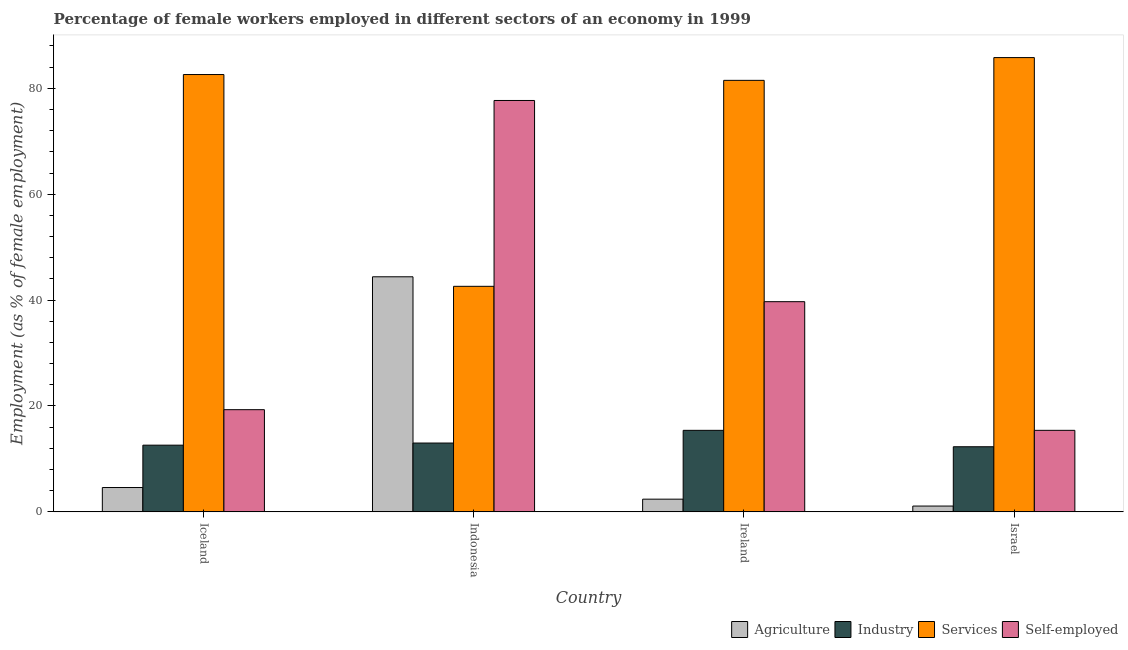How many groups of bars are there?
Your answer should be compact. 4. Are the number of bars per tick equal to the number of legend labels?
Your answer should be very brief. Yes. Are the number of bars on each tick of the X-axis equal?
Provide a succinct answer. Yes. How many bars are there on the 1st tick from the left?
Make the answer very short. 4. How many bars are there on the 4th tick from the right?
Your answer should be compact. 4. In how many cases, is the number of bars for a given country not equal to the number of legend labels?
Your response must be concise. 0. What is the percentage of self employed female workers in Israel?
Provide a succinct answer. 15.4. Across all countries, what is the maximum percentage of female workers in agriculture?
Offer a terse response. 44.4. Across all countries, what is the minimum percentage of female workers in services?
Ensure brevity in your answer.  42.6. In which country was the percentage of female workers in industry maximum?
Give a very brief answer. Ireland. In which country was the percentage of self employed female workers minimum?
Keep it short and to the point. Israel. What is the total percentage of female workers in services in the graph?
Offer a very short reply. 292.5. What is the difference between the percentage of self employed female workers in Iceland and that in Ireland?
Offer a very short reply. -20.4. What is the difference between the percentage of female workers in services in Israel and the percentage of self employed female workers in Iceland?
Your answer should be compact. 66.5. What is the average percentage of self employed female workers per country?
Your answer should be compact. 38.02. What is the difference between the percentage of female workers in agriculture and percentage of self employed female workers in Indonesia?
Your answer should be very brief. -33.3. In how many countries, is the percentage of female workers in services greater than 12 %?
Provide a succinct answer. 4. What is the ratio of the percentage of female workers in agriculture in Iceland to that in Indonesia?
Keep it short and to the point. 0.1. What is the difference between the highest and the second highest percentage of female workers in agriculture?
Your answer should be compact. 39.8. What is the difference between the highest and the lowest percentage of female workers in agriculture?
Your answer should be very brief. 43.3. In how many countries, is the percentage of female workers in industry greater than the average percentage of female workers in industry taken over all countries?
Ensure brevity in your answer.  1. Is the sum of the percentage of female workers in services in Iceland and Ireland greater than the maximum percentage of female workers in agriculture across all countries?
Your response must be concise. Yes. Is it the case that in every country, the sum of the percentage of female workers in services and percentage of self employed female workers is greater than the sum of percentage of female workers in agriculture and percentage of female workers in industry?
Give a very brief answer. No. What does the 3rd bar from the left in Ireland represents?
Offer a terse response. Services. What does the 2nd bar from the right in Indonesia represents?
Give a very brief answer. Services. How many bars are there?
Make the answer very short. 16. Are all the bars in the graph horizontal?
Your response must be concise. No. How many countries are there in the graph?
Ensure brevity in your answer.  4. What is the difference between two consecutive major ticks on the Y-axis?
Your response must be concise. 20. Where does the legend appear in the graph?
Provide a short and direct response. Bottom right. How many legend labels are there?
Give a very brief answer. 4. What is the title of the graph?
Provide a succinct answer. Percentage of female workers employed in different sectors of an economy in 1999. What is the label or title of the X-axis?
Provide a short and direct response. Country. What is the label or title of the Y-axis?
Your answer should be compact. Employment (as % of female employment). What is the Employment (as % of female employment) of Agriculture in Iceland?
Your answer should be compact. 4.6. What is the Employment (as % of female employment) of Industry in Iceland?
Give a very brief answer. 12.6. What is the Employment (as % of female employment) of Services in Iceland?
Provide a short and direct response. 82.6. What is the Employment (as % of female employment) of Self-employed in Iceland?
Keep it short and to the point. 19.3. What is the Employment (as % of female employment) in Agriculture in Indonesia?
Provide a short and direct response. 44.4. What is the Employment (as % of female employment) of Industry in Indonesia?
Ensure brevity in your answer.  13. What is the Employment (as % of female employment) of Services in Indonesia?
Your answer should be compact. 42.6. What is the Employment (as % of female employment) in Self-employed in Indonesia?
Offer a very short reply. 77.7. What is the Employment (as % of female employment) of Agriculture in Ireland?
Make the answer very short. 2.4. What is the Employment (as % of female employment) of Industry in Ireland?
Offer a very short reply. 15.4. What is the Employment (as % of female employment) of Services in Ireland?
Your answer should be compact. 81.5. What is the Employment (as % of female employment) of Self-employed in Ireland?
Your answer should be compact. 39.7. What is the Employment (as % of female employment) of Agriculture in Israel?
Offer a terse response. 1.1. What is the Employment (as % of female employment) of Industry in Israel?
Offer a very short reply. 12.3. What is the Employment (as % of female employment) in Services in Israel?
Provide a short and direct response. 85.8. What is the Employment (as % of female employment) in Self-employed in Israel?
Provide a short and direct response. 15.4. Across all countries, what is the maximum Employment (as % of female employment) in Agriculture?
Offer a very short reply. 44.4. Across all countries, what is the maximum Employment (as % of female employment) in Industry?
Offer a terse response. 15.4. Across all countries, what is the maximum Employment (as % of female employment) in Services?
Make the answer very short. 85.8. Across all countries, what is the maximum Employment (as % of female employment) of Self-employed?
Provide a succinct answer. 77.7. Across all countries, what is the minimum Employment (as % of female employment) of Agriculture?
Your answer should be very brief. 1.1. Across all countries, what is the minimum Employment (as % of female employment) in Industry?
Make the answer very short. 12.3. Across all countries, what is the minimum Employment (as % of female employment) of Services?
Provide a short and direct response. 42.6. Across all countries, what is the minimum Employment (as % of female employment) of Self-employed?
Provide a short and direct response. 15.4. What is the total Employment (as % of female employment) in Agriculture in the graph?
Your answer should be very brief. 52.5. What is the total Employment (as % of female employment) in Industry in the graph?
Provide a succinct answer. 53.3. What is the total Employment (as % of female employment) of Services in the graph?
Ensure brevity in your answer.  292.5. What is the total Employment (as % of female employment) in Self-employed in the graph?
Give a very brief answer. 152.1. What is the difference between the Employment (as % of female employment) of Agriculture in Iceland and that in Indonesia?
Provide a short and direct response. -39.8. What is the difference between the Employment (as % of female employment) of Industry in Iceland and that in Indonesia?
Provide a short and direct response. -0.4. What is the difference between the Employment (as % of female employment) in Services in Iceland and that in Indonesia?
Your answer should be very brief. 40. What is the difference between the Employment (as % of female employment) of Self-employed in Iceland and that in Indonesia?
Keep it short and to the point. -58.4. What is the difference between the Employment (as % of female employment) of Agriculture in Iceland and that in Ireland?
Make the answer very short. 2.2. What is the difference between the Employment (as % of female employment) of Self-employed in Iceland and that in Ireland?
Provide a succinct answer. -20.4. What is the difference between the Employment (as % of female employment) in Agriculture in Iceland and that in Israel?
Offer a terse response. 3.5. What is the difference between the Employment (as % of female employment) in Industry in Iceland and that in Israel?
Provide a succinct answer. 0.3. What is the difference between the Employment (as % of female employment) of Self-employed in Iceland and that in Israel?
Offer a terse response. 3.9. What is the difference between the Employment (as % of female employment) of Agriculture in Indonesia and that in Ireland?
Give a very brief answer. 42. What is the difference between the Employment (as % of female employment) of Industry in Indonesia and that in Ireland?
Offer a terse response. -2.4. What is the difference between the Employment (as % of female employment) in Services in Indonesia and that in Ireland?
Make the answer very short. -38.9. What is the difference between the Employment (as % of female employment) in Agriculture in Indonesia and that in Israel?
Make the answer very short. 43.3. What is the difference between the Employment (as % of female employment) of Industry in Indonesia and that in Israel?
Offer a very short reply. 0.7. What is the difference between the Employment (as % of female employment) in Services in Indonesia and that in Israel?
Keep it short and to the point. -43.2. What is the difference between the Employment (as % of female employment) in Self-employed in Indonesia and that in Israel?
Provide a succinct answer. 62.3. What is the difference between the Employment (as % of female employment) of Self-employed in Ireland and that in Israel?
Keep it short and to the point. 24.3. What is the difference between the Employment (as % of female employment) of Agriculture in Iceland and the Employment (as % of female employment) of Industry in Indonesia?
Provide a short and direct response. -8.4. What is the difference between the Employment (as % of female employment) in Agriculture in Iceland and the Employment (as % of female employment) in Services in Indonesia?
Provide a short and direct response. -38. What is the difference between the Employment (as % of female employment) in Agriculture in Iceland and the Employment (as % of female employment) in Self-employed in Indonesia?
Offer a very short reply. -73.1. What is the difference between the Employment (as % of female employment) of Industry in Iceland and the Employment (as % of female employment) of Self-employed in Indonesia?
Provide a short and direct response. -65.1. What is the difference between the Employment (as % of female employment) of Agriculture in Iceland and the Employment (as % of female employment) of Services in Ireland?
Make the answer very short. -76.9. What is the difference between the Employment (as % of female employment) in Agriculture in Iceland and the Employment (as % of female employment) in Self-employed in Ireland?
Your answer should be compact. -35.1. What is the difference between the Employment (as % of female employment) in Industry in Iceland and the Employment (as % of female employment) in Services in Ireland?
Offer a terse response. -68.9. What is the difference between the Employment (as % of female employment) in Industry in Iceland and the Employment (as % of female employment) in Self-employed in Ireland?
Ensure brevity in your answer.  -27.1. What is the difference between the Employment (as % of female employment) in Services in Iceland and the Employment (as % of female employment) in Self-employed in Ireland?
Your answer should be compact. 42.9. What is the difference between the Employment (as % of female employment) of Agriculture in Iceland and the Employment (as % of female employment) of Services in Israel?
Offer a terse response. -81.2. What is the difference between the Employment (as % of female employment) in Agriculture in Iceland and the Employment (as % of female employment) in Self-employed in Israel?
Your answer should be compact. -10.8. What is the difference between the Employment (as % of female employment) in Industry in Iceland and the Employment (as % of female employment) in Services in Israel?
Give a very brief answer. -73.2. What is the difference between the Employment (as % of female employment) of Industry in Iceland and the Employment (as % of female employment) of Self-employed in Israel?
Your answer should be compact. -2.8. What is the difference between the Employment (as % of female employment) in Services in Iceland and the Employment (as % of female employment) in Self-employed in Israel?
Your answer should be compact. 67.2. What is the difference between the Employment (as % of female employment) of Agriculture in Indonesia and the Employment (as % of female employment) of Industry in Ireland?
Ensure brevity in your answer.  29. What is the difference between the Employment (as % of female employment) in Agriculture in Indonesia and the Employment (as % of female employment) in Services in Ireland?
Provide a succinct answer. -37.1. What is the difference between the Employment (as % of female employment) of Industry in Indonesia and the Employment (as % of female employment) of Services in Ireland?
Your answer should be compact. -68.5. What is the difference between the Employment (as % of female employment) in Industry in Indonesia and the Employment (as % of female employment) in Self-employed in Ireland?
Provide a succinct answer. -26.7. What is the difference between the Employment (as % of female employment) in Services in Indonesia and the Employment (as % of female employment) in Self-employed in Ireland?
Provide a succinct answer. 2.9. What is the difference between the Employment (as % of female employment) in Agriculture in Indonesia and the Employment (as % of female employment) in Industry in Israel?
Your answer should be very brief. 32.1. What is the difference between the Employment (as % of female employment) in Agriculture in Indonesia and the Employment (as % of female employment) in Services in Israel?
Offer a very short reply. -41.4. What is the difference between the Employment (as % of female employment) in Industry in Indonesia and the Employment (as % of female employment) in Services in Israel?
Your response must be concise. -72.8. What is the difference between the Employment (as % of female employment) in Industry in Indonesia and the Employment (as % of female employment) in Self-employed in Israel?
Provide a short and direct response. -2.4. What is the difference between the Employment (as % of female employment) in Services in Indonesia and the Employment (as % of female employment) in Self-employed in Israel?
Your answer should be very brief. 27.2. What is the difference between the Employment (as % of female employment) in Agriculture in Ireland and the Employment (as % of female employment) in Industry in Israel?
Provide a short and direct response. -9.9. What is the difference between the Employment (as % of female employment) in Agriculture in Ireland and the Employment (as % of female employment) in Services in Israel?
Keep it short and to the point. -83.4. What is the difference between the Employment (as % of female employment) of Agriculture in Ireland and the Employment (as % of female employment) of Self-employed in Israel?
Your answer should be very brief. -13. What is the difference between the Employment (as % of female employment) in Industry in Ireland and the Employment (as % of female employment) in Services in Israel?
Ensure brevity in your answer.  -70.4. What is the difference between the Employment (as % of female employment) of Services in Ireland and the Employment (as % of female employment) of Self-employed in Israel?
Your response must be concise. 66.1. What is the average Employment (as % of female employment) of Agriculture per country?
Provide a short and direct response. 13.12. What is the average Employment (as % of female employment) in Industry per country?
Provide a succinct answer. 13.32. What is the average Employment (as % of female employment) of Services per country?
Provide a short and direct response. 73.12. What is the average Employment (as % of female employment) of Self-employed per country?
Your answer should be compact. 38.02. What is the difference between the Employment (as % of female employment) of Agriculture and Employment (as % of female employment) of Industry in Iceland?
Keep it short and to the point. -8. What is the difference between the Employment (as % of female employment) of Agriculture and Employment (as % of female employment) of Services in Iceland?
Ensure brevity in your answer.  -78. What is the difference between the Employment (as % of female employment) in Agriculture and Employment (as % of female employment) in Self-employed in Iceland?
Keep it short and to the point. -14.7. What is the difference between the Employment (as % of female employment) in Industry and Employment (as % of female employment) in Services in Iceland?
Your answer should be compact. -70. What is the difference between the Employment (as % of female employment) of Industry and Employment (as % of female employment) of Self-employed in Iceland?
Your answer should be compact. -6.7. What is the difference between the Employment (as % of female employment) in Services and Employment (as % of female employment) in Self-employed in Iceland?
Offer a terse response. 63.3. What is the difference between the Employment (as % of female employment) in Agriculture and Employment (as % of female employment) in Industry in Indonesia?
Keep it short and to the point. 31.4. What is the difference between the Employment (as % of female employment) of Agriculture and Employment (as % of female employment) of Services in Indonesia?
Provide a succinct answer. 1.8. What is the difference between the Employment (as % of female employment) in Agriculture and Employment (as % of female employment) in Self-employed in Indonesia?
Give a very brief answer. -33.3. What is the difference between the Employment (as % of female employment) in Industry and Employment (as % of female employment) in Services in Indonesia?
Your answer should be compact. -29.6. What is the difference between the Employment (as % of female employment) of Industry and Employment (as % of female employment) of Self-employed in Indonesia?
Offer a terse response. -64.7. What is the difference between the Employment (as % of female employment) in Services and Employment (as % of female employment) in Self-employed in Indonesia?
Provide a short and direct response. -35.1. What is the difference between the Employment (as % of female employment) of Agriculture and Employment (as % of female employment) of Services in Ireland?
Keep it short and to the point. -79.1. What is the difference between the Employment (as % of female employment) of Agriculture and Employment (as % of female employment) of Self-employed in Ireland?
Offer a very short reply. -37.3. What is the difference between the Employment (as % of female employment) in Industry and Employment (as % of female employment) in Services in Ireland?
Offer a terse response. -66.1. What is the difference between the Employment (as % of female employment) in Industry and Employment (as % of female employment) in Self-employed in Ireland?
Make the answer very short. -24.3. What is the difference between the Employment (as % of female employment) of Services and Employment (as % of female employment) of Self-employed in Ireland?
Make the answer very short. 41.8. What is the difference between the Employment (as % of female employment) of Agriculture and Employment (as % of female employment) of Industry in Israel?
Offer a very short reply. -11.2. What is the difference between the Employment (as % of female employment) in Agriculture and Employment (as % of female employment) in Services in Israel?
Offer a terse response. -84.7. What is the difference between the Employment (as % of female employment) in Agriculture and Employment (as % of female employment) in Self-employed in Israel?
Offer a very short reply. -14.3. What is the difference between the Employment (as % of female employment) of Industry and Employment (as % of female employment) of Services in Israel?
Your answer should be very brief. -73.5. What is the difference between the Employment (as % of female employment) of Industry and Employment (as % of female employment) of Self-employed in Israel?
Your response must be concise. -3.1. What is the difference between the Employment (as % of female employment) of Services and Employment (as % of female employment) of Self-employed in Israel?
Offer a terse response. 70.4. What is the ratio of the Employment (as % of female employment) in Agriculture in Iceland to that in Indonesia?
Your answer should be compact. 0.1. What is the ratio of the Employment (as % of female employment) of Industry in Iceland to that in Indonesia?
Offer a terse response. 0.97. What is the ratio of the Employment (as % of female employment) in Services in Iceland to that in Indonesia?
Give a very brief answer. 1.94. What is the ratio of the Employment (as % of female employment) of Self-employed in Iceland to that in Indonesia?
Ensure brevity in your answer.  0.25. What is the ratio of the Employment (as % of female employment) of Agriculture in Iceland to that in Ireland?
Ensure brevity in your answer.  1.92. What is the ratio of the Employment (as % of female employment) in Industry in Iceland to that in Ireland?
Your answer should be compact. 0.82. What is the ratio of the Employment (as % of female employment) in Services in Iceland to that in Ireland?
Keep it short and to the point. 1.01. What is the ratio of the Employment (as % of female employment) in Self-employed in Iceland to that in Ireland?
Make the answer very short. 0.49. What is the ratio of the Employment (as % of female employment) of Agriculture in Iceland to that in Israel?
Your answer should be compact. 4.18. What is the ratio of the Employment (as % of female employment) of Industry in Iceland to that in Israel?
Provide a short and direct response. 1.02. What is the ratio of the Employment (as % of female employment) in Services in Iceland to that in Israel?
Offer a very short reply. 0.96. What is the ratio of the Employment (as % of female employment) of Self-employed in Iceland to that in Israel?
Give a very brief answer. 1.25. What is the ratio of the Employment (as % of female employment) in Agriculture in Indonesia to that in Ireland?
Keep it short and to the point. 18.5. What is the ratio of the Employment (as % of female employment) of Industry in Indonesia to that in Ireland?
Offer a very short reply. 0.84. What is the ratio of the Employment (as % of female employment) of Services in Indonesia to that in Ireland?
Provide a succinct answer. 0.52. What is the ratio of the Employment (as % of female employment) of Self-employed in Indonesia to that in Ireland?
Provide a succinct answer. 1.96. What is the ratio of the Employment (as % of female employment) in Agriculture in Indonesia to that in Israel?
Keep it short and to the point. 40.36. What is the ratio of the Employment (as % of female employment) in Industry in Indonesia to that in Israel?
Your answer should be compact. 1.06. What is the ratio of the Employment (as % of female employment) in Services in Indonesia to that in Israel?
Your answer should be compact. 0.5. What is the ratio of the Employment (as % of female employment) of Self-employed in Indonesia to that in Israel?
Your answer should be compact. 5.05. What is the ratio of the Employment (as % of female employment) of Agriculture in Ireland to that in Israel?
Ensure brevity in your answer.  2.18. What is the ratio of the Employment (as % of female employment) of Industry in Ireland to that in Israel?
Keep it short and to the point. 1.25. What is the ratio of the Employment (as % of female employment) in Services in Ireland to that in Israel?
Your answer should be very brief. 0.95. What is the ratio of the Employment (as % of female employment) in Self-employed in Ireland to that in Israel?
Your answer should be compact. 2.58. What is the difference between the highest and the second highest Employment (as % of female employment) of Agriculture?
Your answer should be very brief. 39.8. What is the difference between the highest and the second highest Employment (as % of female employment) in Self-employed?
Offer a very short reply. 38. What is the difference between the highest and the lowest Employment (as % of female employment) in Agriculture?
Offer a very short reply. 43.3. What is the difference between the highest and the lowest Employment (as % of female employment) of Services?
Your answer should be very brief. 43.2. What is the difference between the highest and the lowest Employment (as % of female employment) in Self-employed?
Your answer should be compact. 62.3. 